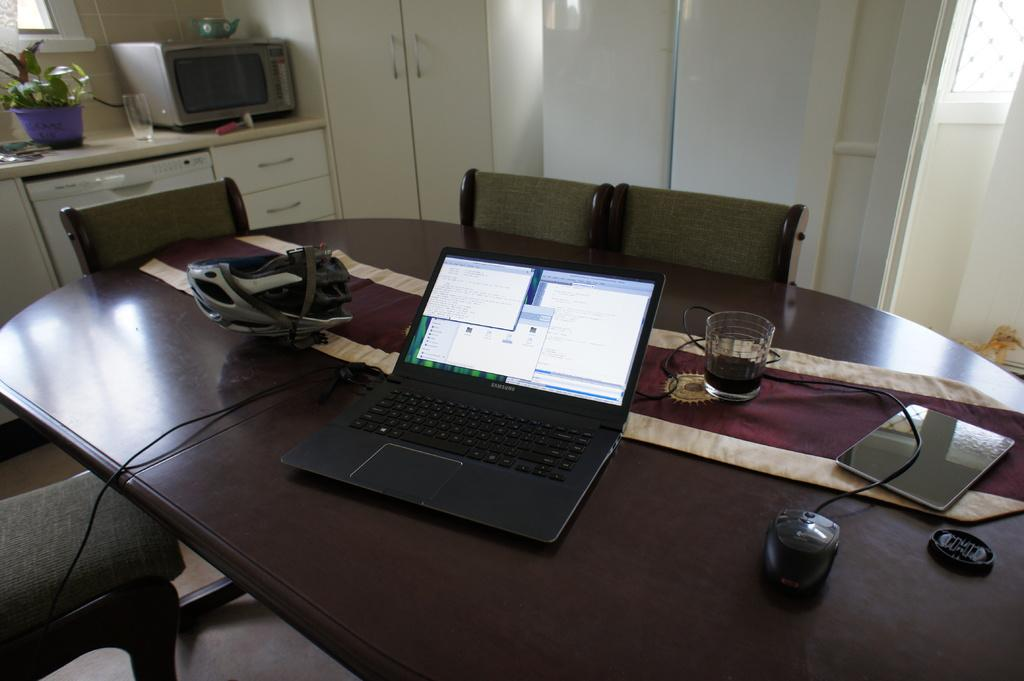What electronic device is on the table in the image? There is a laptop on the table in the image. What accessory is also on the table? There is a mouse on the table. What type of beverage might be in the glass on the table? There is a glass with a drink in it on the table. What type of container is on the table? There is a tab on the table. What type of protective gear is on the table? There is a helmet on the table. How many chairs are around the table? There is a group of chairs around the table. What appliance is in the left corner of the image? There is a microwave in the left corner of the image. What type of uncle is sitting on the chair in the image? There is no uncle present in the image. What type of process is being carried out in the image? There is no process being carried out in the image; it is a still image of objects on a table. 